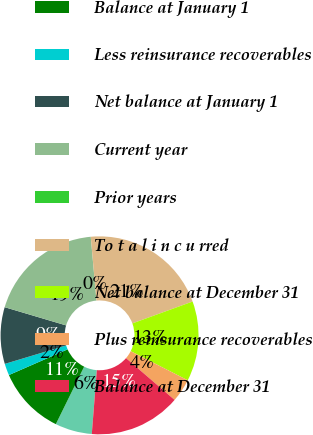Convert chart to OTSL. <chart><loc_0><loc_0><loc_500><loc_500><pie_chart><fcel>(millions)<fcel>Balance at January 1<fcel>Less reinsurance recoverables<fcel>Net balance at January 1<fcel>Current year<fcel>Prior years<fcel>To t a l i n c u rred<fcel>Net balance at December 31<fcel>Plus reinsurance recoverables<fcel>Balance at December 31<nl><fcel>6.03%<fcel>11.15%<fcel>1.91%<fcel>9.25%<fcel>18.98%<fcel>0.01%<fcel>20.87%<fcel>13.05%<fcel>3.81%<fcel>14.94%<nl></chart> 